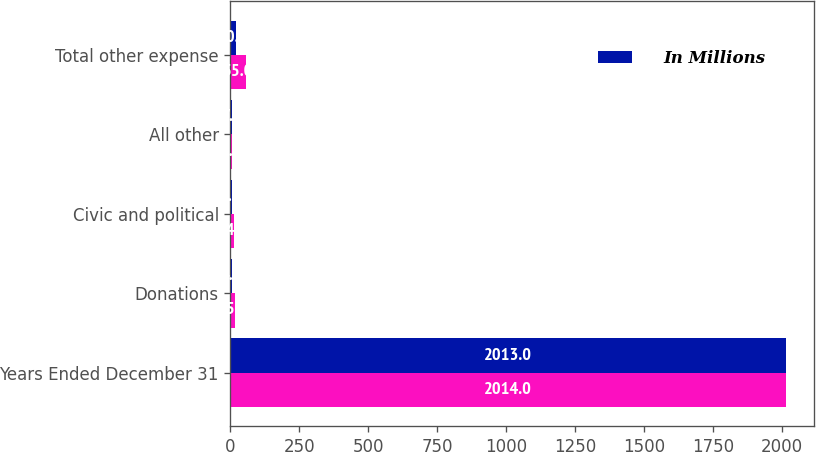Convert chart. <chart><loc_0><loc_0><loc_500><loc_500><stacked_bar_chart><ecel><fcel>Years Ended December 31<fcel>Donations<fcel>Civic and political<fcel>All other<fcel>Total other expense<nl><fcel>nan<fcel>2014<fcel>15<fcel>14<fcel>6<fcel>55<nl><fcel>In Millions<fcel>2013<fcel>4<fcel>5<fcel>7<fcel>20<nl></chart> 